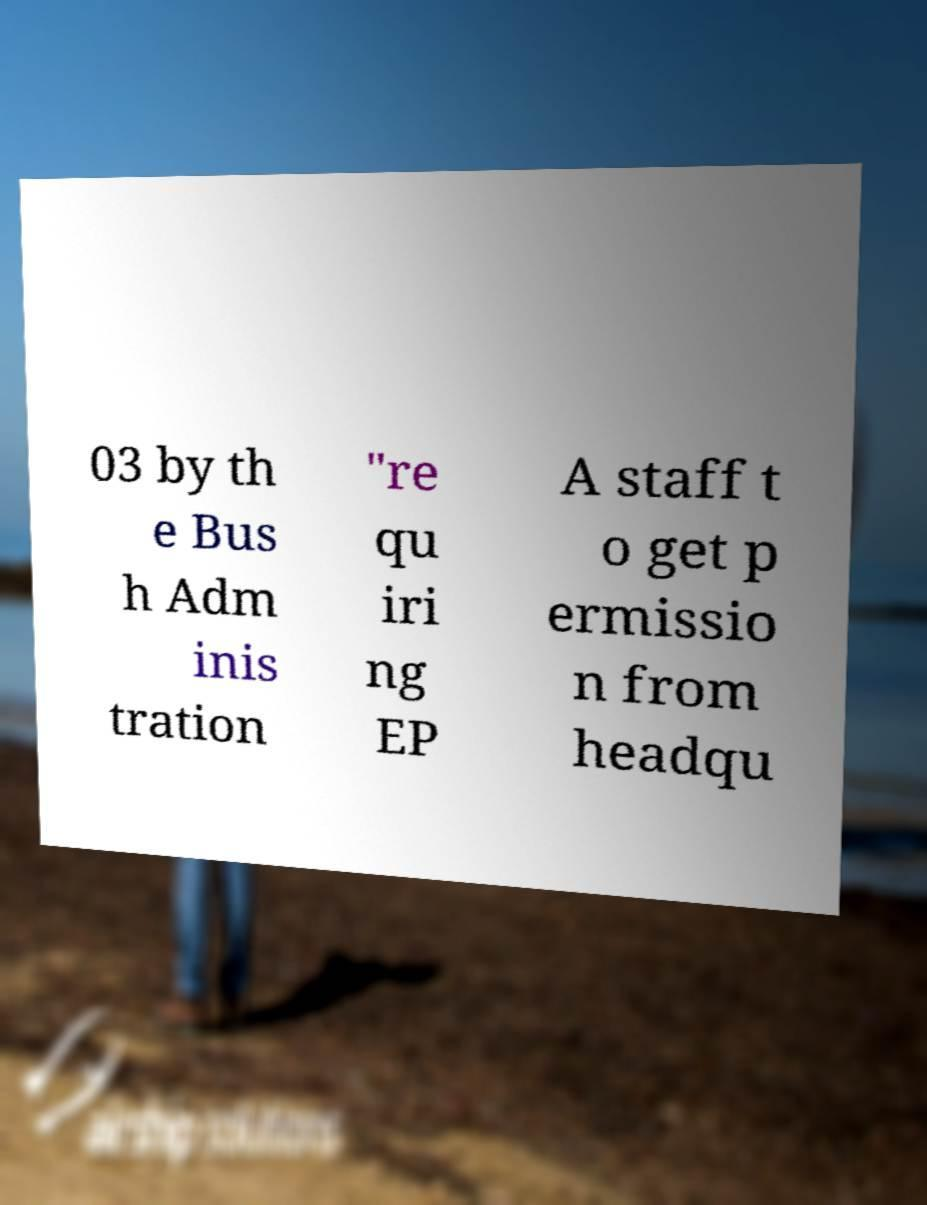What messages or text are displayed in this image? I need them in a readable, typed format. 03 by th e Bus h Adm inis tration "re qu iri ng EP A staff t o get p ermissio n from headqu 